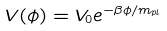Convert formula to latex. <formula><loc_0><loc_0><loc_500><loc_500>V ( \phi ) = V _ { 0 } e ^ { - \beta \phi / m _ { p l } }</formula> 